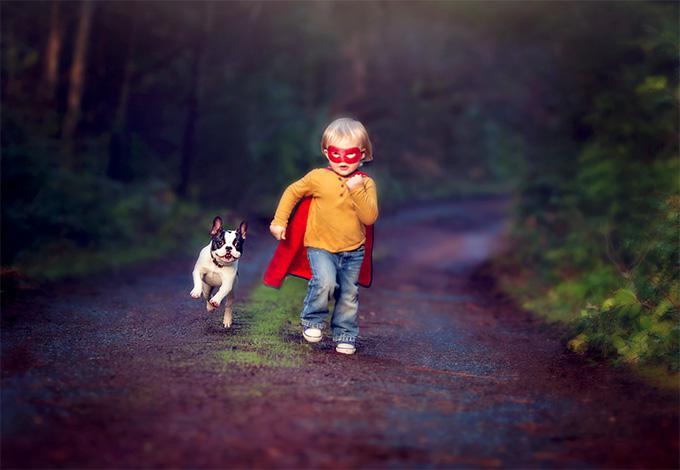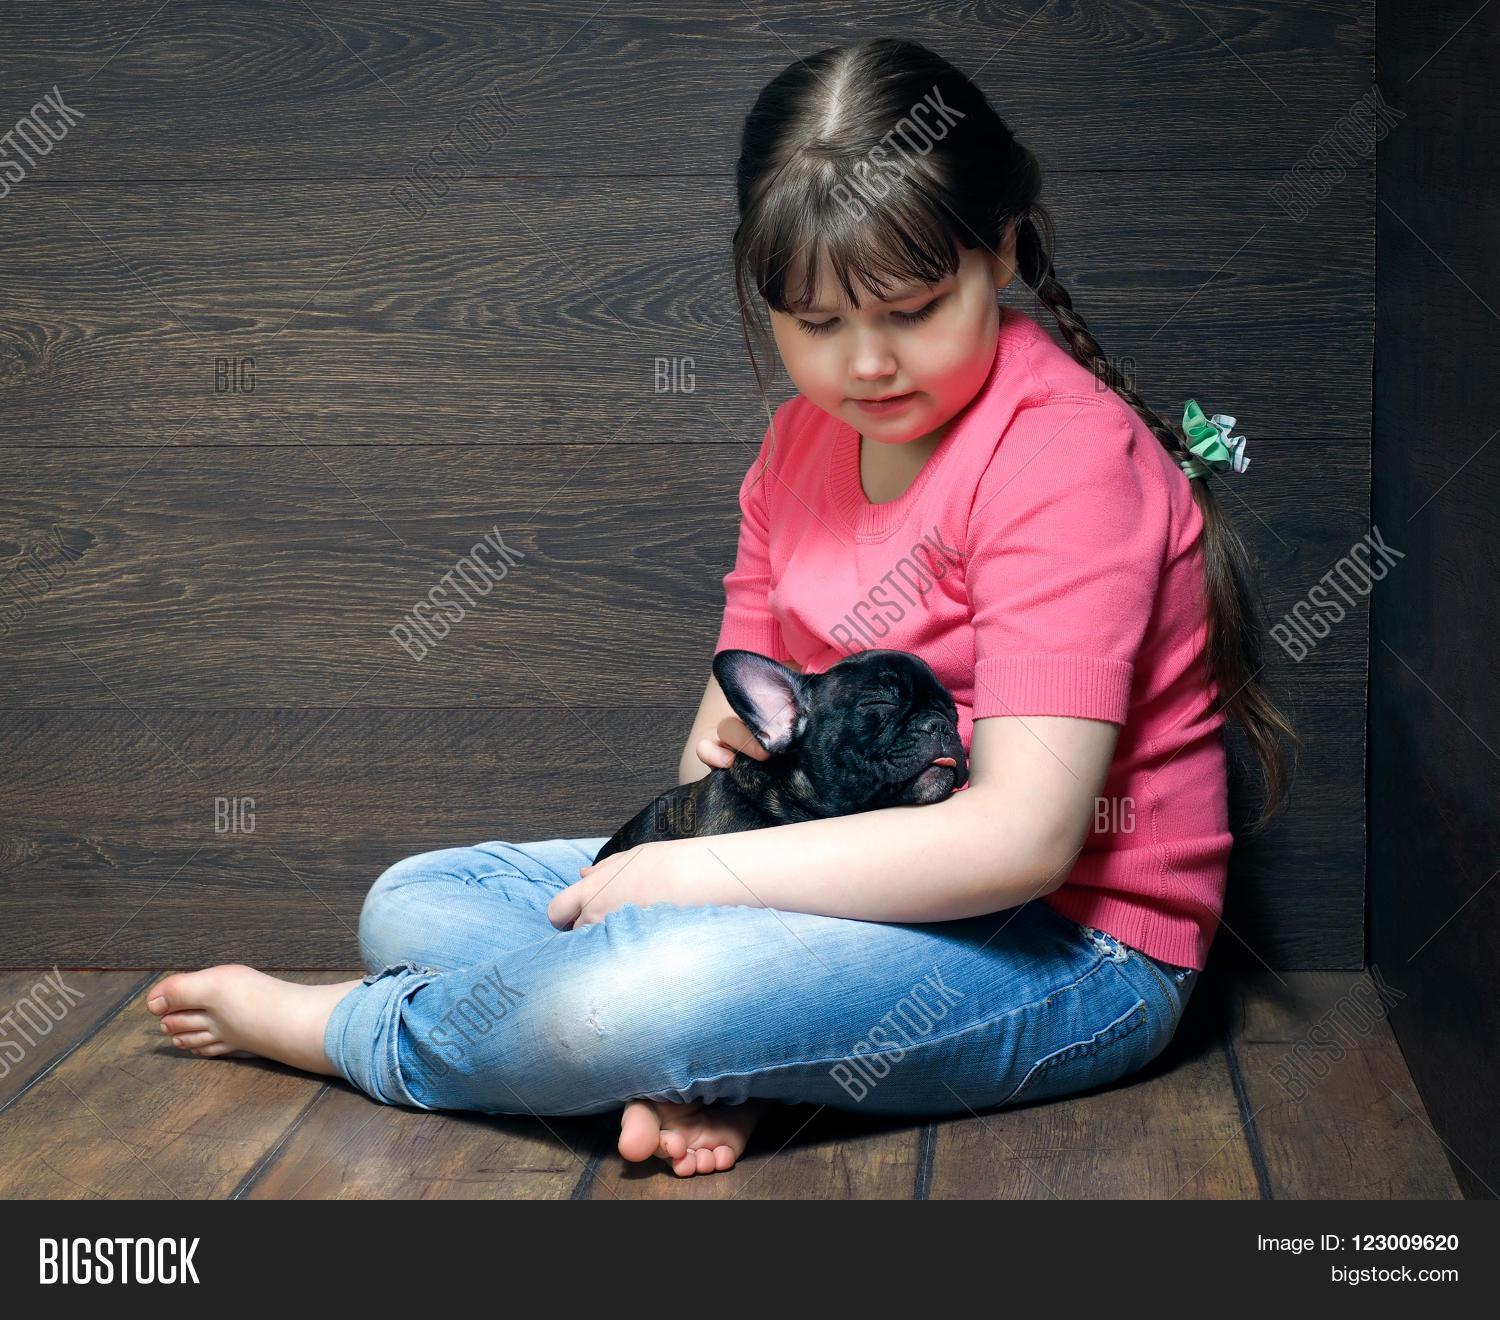The first image is the image on the left, the second image is the image on the right. Assess this claim about the two images: "Each dog is wearing some kind of costume.". Correct or not? Answer yes or no. No. 